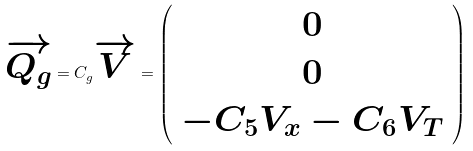<formula> <loc_0><loc_0><loc_500><loc_500>\overrightarrow { Q _ { g } } = C _ { g } \overrightarrow { V } = \left ( \begin{array} { c } 0 \\ 0 \\ - C _ { 5 } V _ { x } - C _ { 6 } V _ { T } \end{array} \right )</formula> 